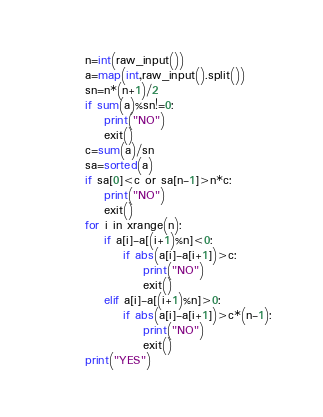Convert code to text. <code><loc_0><loc_0><loc_500><loc_500><_Python_>n=int(raw_input())
a=map(int,raw_input().split())
sn=n*(n+1)/2
if sum(a)%sn!=0:
    print("NO")
    exit()
c=sum(a)/sn
sa=sorted(a)
if sa[0]<c or sa[n-1]>n*c:
    print("NO")
    exit()
for i in xrange(n):
    if a[i]-a[(i+1)%n]<0:
        if abs(a[i]-a[i+1])>c:
            print("NO")
            exit()
    elif a[i]-a[(i+1)%n]>0:
        if abs(a[i]-a[i+1])>c*(n-1):
            print("NO")
            exit()
print("YES")</code> 